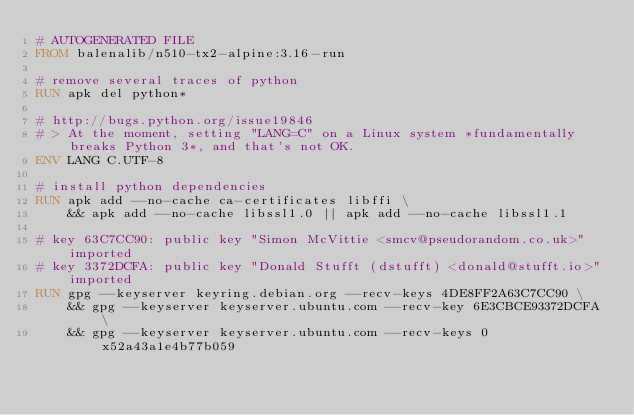<code> <loc_0><loc_0><loc_500><loc_500><_Dockerfile_># AUTOGENERATED FILE
FROM balenalib/n510-tx2-alpine:3.16-run

# remove several traces of python
RUN apk del python*

# http://bugs.python.org/issue19846
# > At the moment, setting "LANG=C" on a Linux system *fundamentally breaks Python 3*, and that's not OK.
ENV LANG C.UTF-8

# install python dependencies
RUN apk add --no-cache ca-certificates libffi \
	&& apk add --no-cache libssl1.0 || apk add --no-cache libssl1.1

# key 63C7CC90: public key "Simon McVittie <smcv@pseudorandom.co.uk>" imported
# key 3372DCFA: public key "Donald Stufft (dstufft) <donald@stufft.io>" imported
RUN gpg --keyserver keyring.debian.org --recv-keys 4DE8FF2A63C7CC90 \
	&& gpg --keyserver keyserver.ubuntu.com --recv-key 6E3CBCE93372DCFA \
	&& gpg --keyserver keyserver.ubuntu.com --recv-keys 0x52a43a1e4b77b059
</code> 